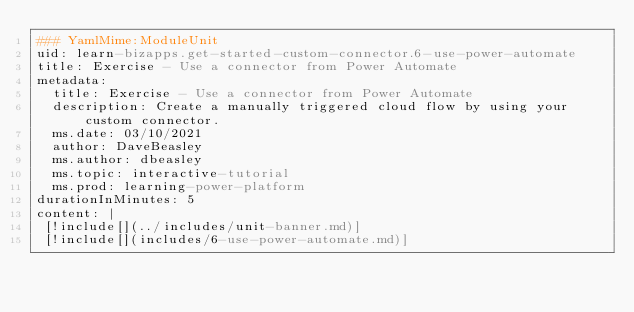Convert code to text. <code><loc_0><loc_0><loc_500><loc_500><_YAML_>### YamlMime:ModuleUnit 
uid: learn-bizapps.get-started-custom-connector.6-use-power-automate 
title: Exercise - Use a connector from Power Automate
metadata: 
  title: Exercise - Use a connector from Power Automate
  description: Create a manually triggered cloud flow by using your custom connector.
  ms.date: 03/10/2021 
  author: DaveBeasley 
  ms.author: dbeasley 
  ms.topic: interactive-tutorial 
  ms.prod: learning-power-platform 
durationInMinutes: 5 
content: | 
 [!include[](../includes/unit-banner.md)] 
 [!include[](includes/6-use-power-automate.md)] 
</code> 